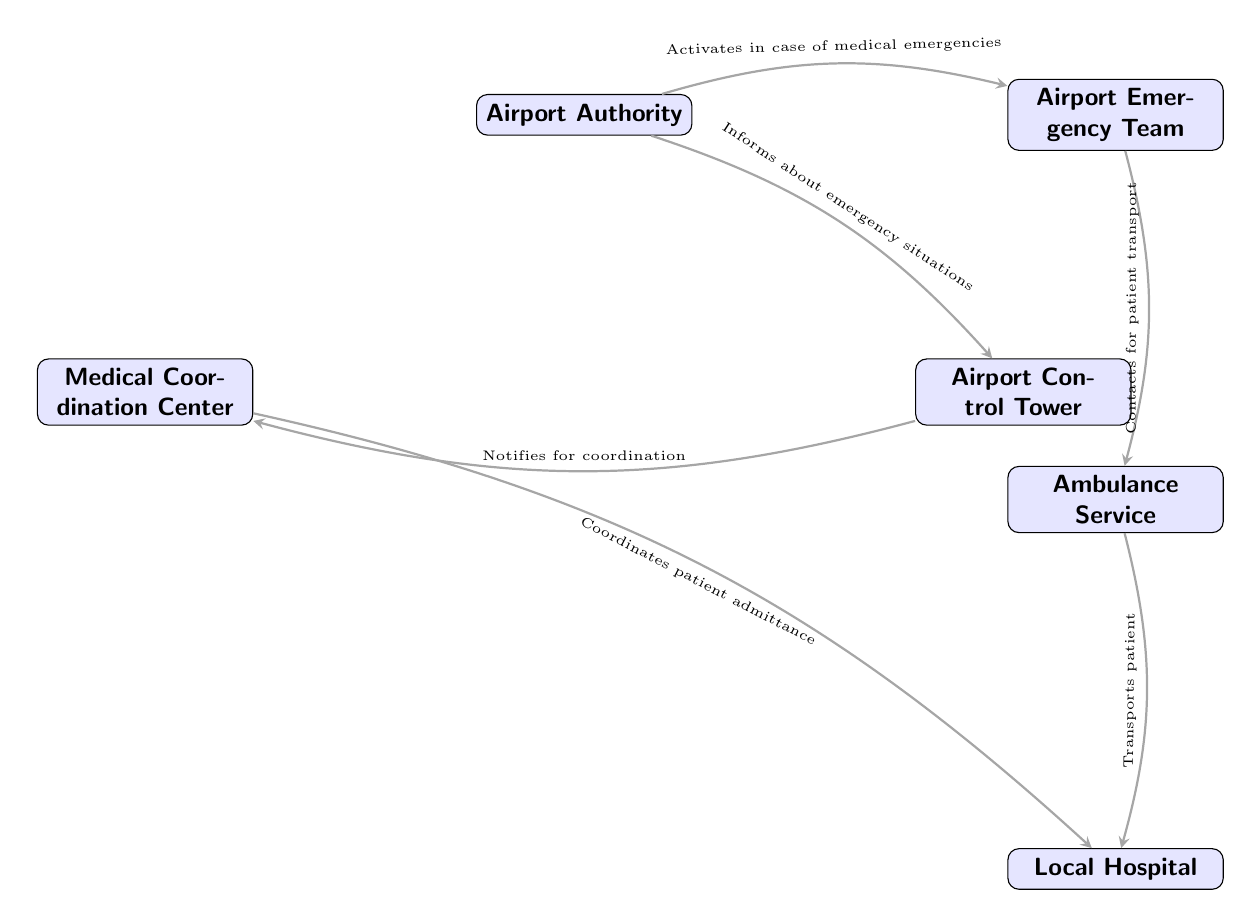What is the first node activated in case of a medical emergency? The diagram indicates that the Airport Authority is responsible for activating the Airport Emergency Team in case of a medical emergency. The arrow pointing from the Airport Authority to the Airport Emergency Team confirms this relationship.
Answer: Airport Authority How many nodes are there in the diagram? Counting all distinct entities represented in the diagram, we find there are six nodes: Airport Authority, Airport Emergency Team, Control Tower, Medical Coordination Center, Ambulance Service, and Local Hospital.
Answer: 6 What service does the Airport Emergency Team contact for patient transport? The diagram clearly shows an arrow pointing from the Airport Emergency Team to the Ambulance Service, indicating that the Airport Emergency Team contacts the Ambulance Service for patient transport.
Answer: Ambulance Service What does the Airport Control Tower notify for? According to the diagram, the Airport Control Tower notifies the Medical Coordination Center for coordination, as indicated by the connecting arrow between them.
Answer: Coordination What is the final destination for patient transport in this diagram? The Ambulance Service, as indicated by the arrow in the diagram, transports the patient to the Local Hospital, which is the final destination.
Answer: Local Hospital What type of service coordinates patient admission to the Local Hospital? The diagram specifies that the Medical Coordination Center is responsible for coordinating patient admittance to the Local Hospital, as shown by the directed edge from the Medical Coordination Center to the Local Hospital.
Answer: Medical Coordination Center What is the relationship between the Airport Authority and the Control Tower? The Airport Authority informs the Control Tower about emergency situations, which is illustrated by an arrow connecting these two nodes in the diagram.
Answer: Informs Who coordinates the communication between the Airport and the Local Hospital? The Medical Coordination Center is the entity that coordinates patient admittance to the Local Hospital, as indicated by the arrow showing the relationship between these two nodes. This coordination is crucial for effective communication in emergencies.
Answer: Medical Coordination Center Which node does the Ambulance Service connect to for patient transport? The diagram shows a direct connection from the Ambulance Service to the Local Hospital, which indicates that the Ambulance Service is responsible for transporting patients to that node.
Answer: Local Hospital 